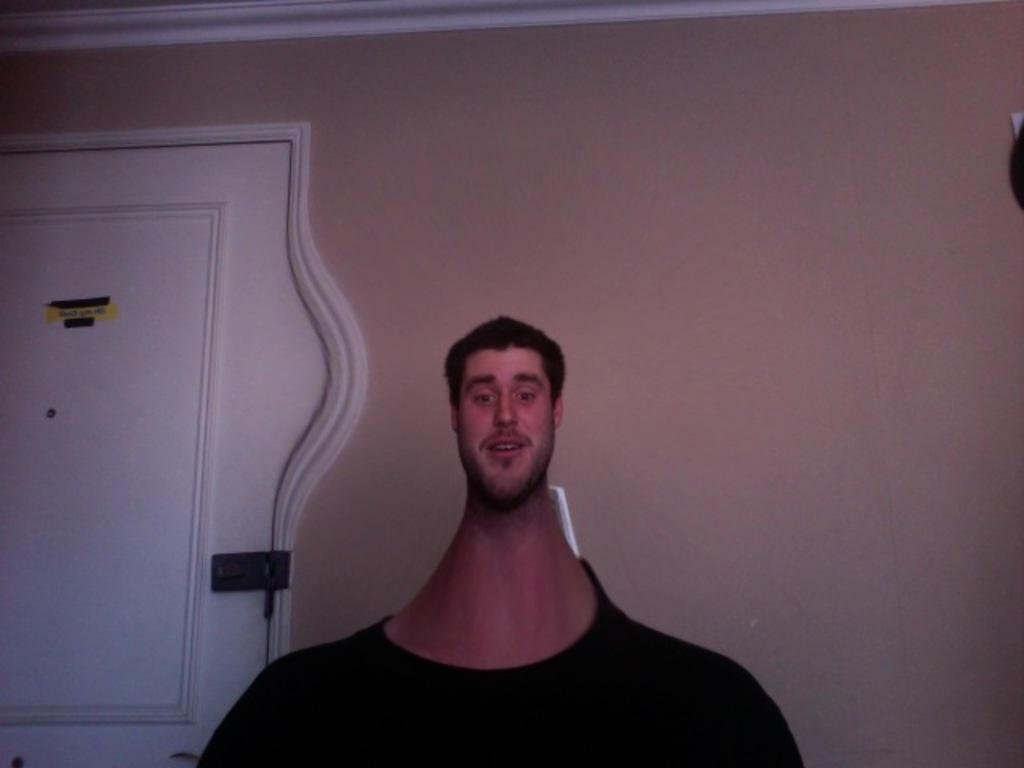Who or what is the main subject in the center of the image? There is a person in the center of the image. What is the person wearing? The person is wearing a black t-shirt. What can be seen on the left side of the image? There is a door on the left side of the image. What is visible in the background of the image? There is a wall in the background of the image. What type of quartz can be seen on the person's wrist in the image? There is no quartz visible on the person's wrist in the image. Is the person in the image part of an army? There is no indication in the image that the person is part of an army. What type of band is playing in the background of the image? There is no band present in the image; it only features a person, a door, and a wall in the background. 